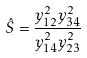<formula> <loc_0><loc_0><loc_500><loc_500>\hat { S } = { \frac { y _ { 1 2 } ^ { 2 } y _ { 3 4 } ^ { 2 } } { y _ { 1 4 } ^ { 2 } y _ { 2 3 } ^ { 2 } } }</formula> 